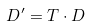Convert formula to latex. <formula><loc_0><loc_0><loc_500><loc_500>D ^ { \prime } = T \cdot D</formula> 